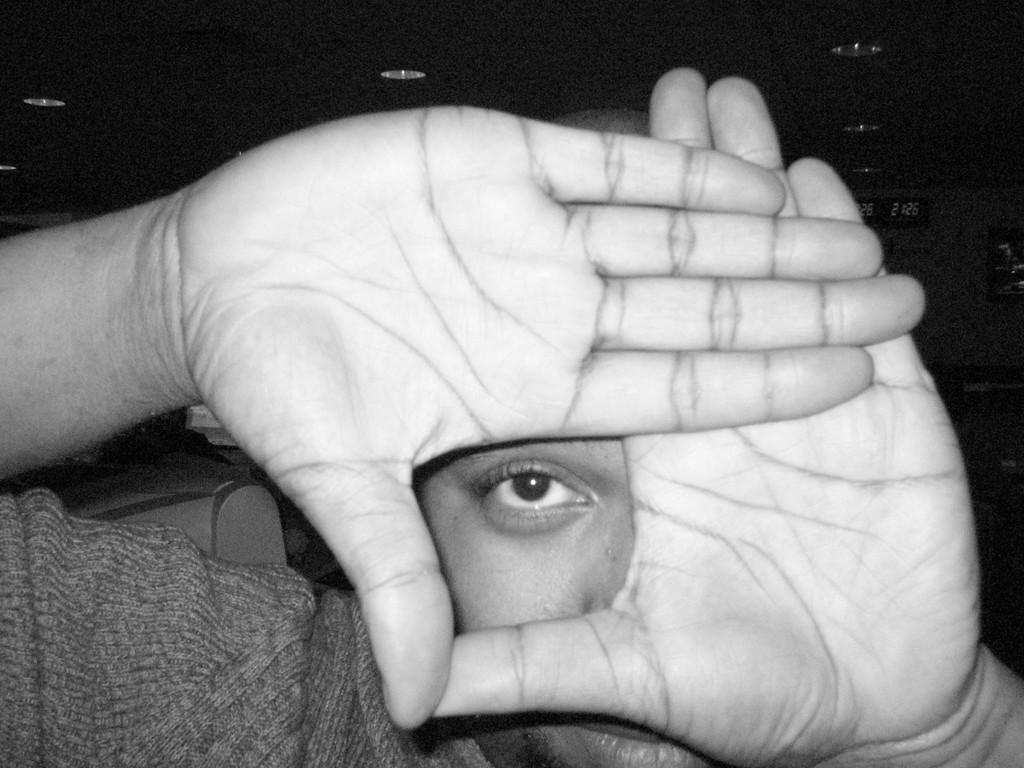What is the person in the image wearing? There is a person wearing a dress in the image. What can be seen in the background of the image? There are boards visible in the background of the image. What is located at the top of the image? There are lights at the top of the image. How does the person in the image plan to pay for their purchase using credit? There is no indication in the image that the person is making a purchase or using credit. 